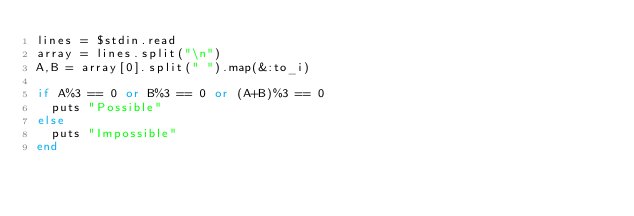<code> <loc_0><loc_0><loc_500><loc_500><_Ruby_>lines = $stdin.read
array = lines.split("\n")
A,B = array[0].split(" ").map(&:to_i)
 
if A%3 == 0 or B%3 == 0 or (A+B)%3 == 0
  puts "Possible"
else
  puts "Impossible"
end</code> 